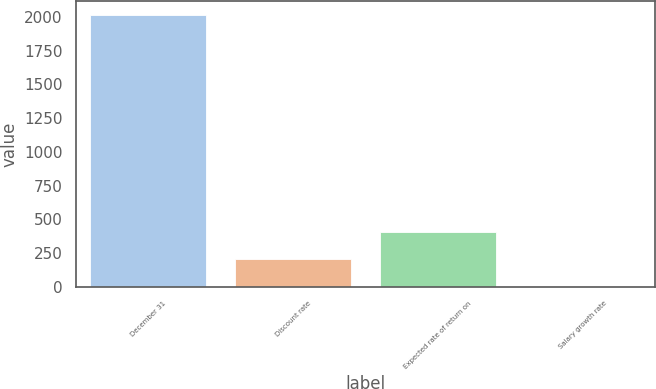Convert chart. <chart><loc_0><loc_0><loc_500><loc_500><bar_chart><fcel>December 31<fcel>Discount rate<fcel>Expected rate of return on<fcel>Salary growth rate<nl><fcel>2016<fcel>205.47<fcel>406.64<fcel>4.3<nl></chart> 